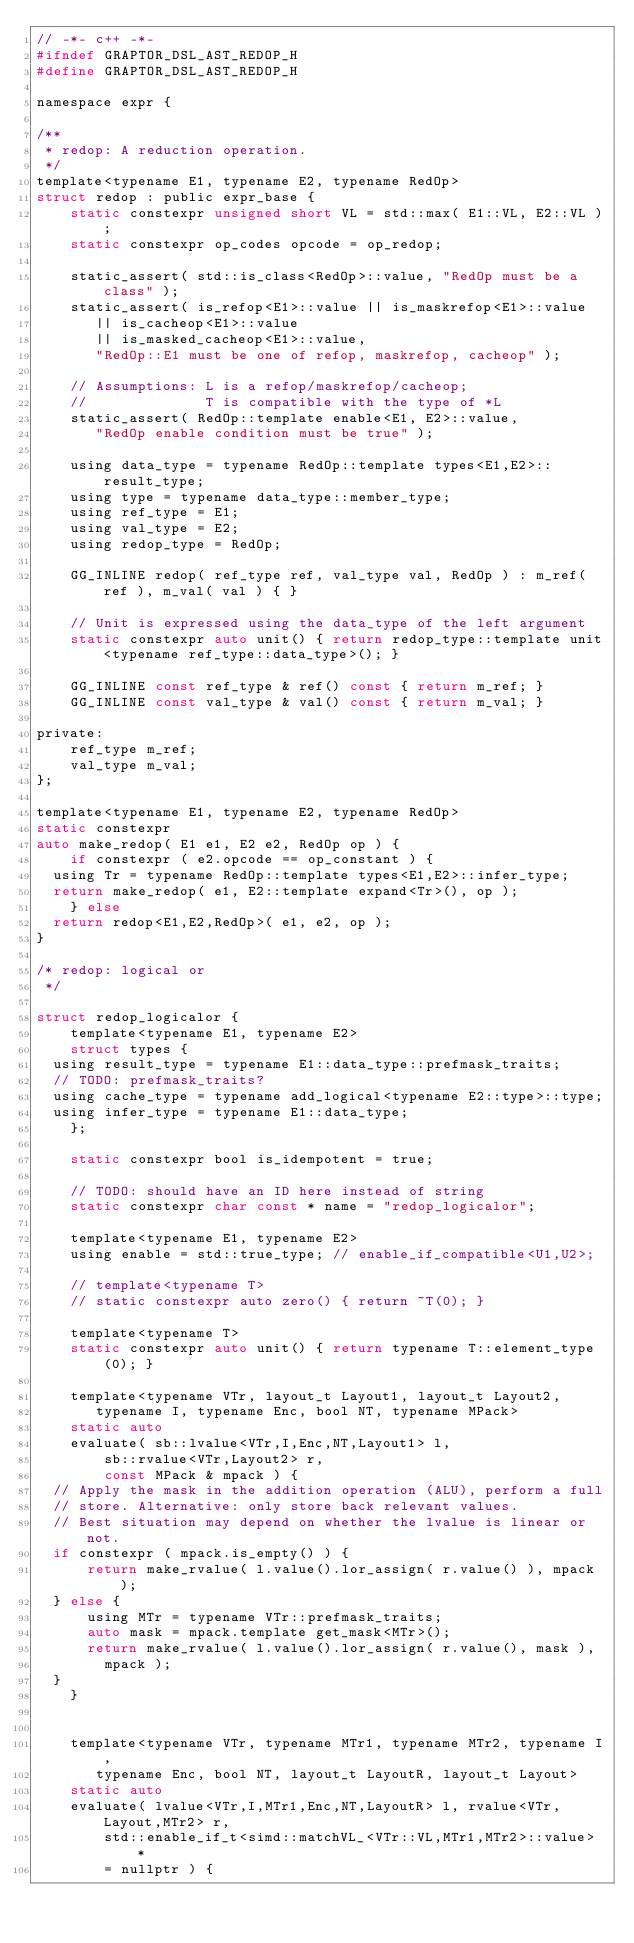<code> <loc_0><loc_0><loc_500><loc_500><_C_>// -*- c++ -*-
#ifndef GRAPTOR_DSL_AST_REDOP_H
#define GRAPTOR_DSL_AST_REDOP_H

namespace expr {

/**
 * redop: A reduction operation.
 */
template<typename E1, typename E2, typename RedOp>
struct redop : public expr_base {
    static constexpr unsigned short VL = std::max( E1::VL, E2::VL );
    static constexpr op_codes opcode = op_redop;

    static_assert( std::is_class<RedOp>::value, "RedOp must be a class" );
    static_assert( is_refop<E1>::value || is_maskrefop<E1>::value
		   || is_cacheop<E1>::value
		   || is_masked_cacheop<E1>::value,
		   "RedOp::E1 must be one of refop, maskrefop, cacheop" );

    // Assumptions: L is a refop/maskrefop/cacheop;
    //              T is compatible with the type of *L
    static_assert( RedOp::template enable<E1, E2>::value,
		   "RedOp enable condition must be true" );

    using data_type = typename RedOp::template types<E1,E2>::result_type;
    using type = typename data_type::member_type;
    using ref_type = E1;
    using val_type = E2;
    using redop_type = RedOp;

    GG_INLINE redop( ref_type ref, val_type val, RedOp ) : m_ref( ref ), m_val( val ) { }

    // Unit is expressed using the data_type of the left argument
    static constexpr auto unit() { return redop_type::template unit<typename ref_type::data_type>(); }

    GG_INLINE const ref_type & ref() const { return m_ref; }
    GG_INLINE const val_type & val() const { return m_val; }

private:
    ref_type m_ref;
    val_type m_val;
};

template<typename E1, typename E2, typename RedOp>
static constexpr
auto make_redop( E1 e1, E2 e2, RedOp op ) {
    if constexpr ( e2.opcode == op_constant ) {
	using Tr = typename RedOp::template types<E1,E2>::infer_type;
	return make_redop( e1, E2::template expand<Tr>(), op );
    } else
	return redop<E1,E2,RedOp>( e1, e2, op );
}

/* redop: logical or
 */

struct redop_logicalor {
    template<typename E1, typename E2>
    struct types {
	using result_type = typename E1::data_type::prefmask_traits;
	// TODO: prefmask_traits?
	using cache_type = typename add_logical<typename E2::type>::type;
	using infer_type = typename E1::data_type;
    };

    static constexpr bool is_idempotent = true;

    // TODO: should have an ID here instead of string
    static constexpr char const * name = "redop_logicalor";

    template<typename E1, typename E2>
    using enable = std::true_type; // enable_if_compatible<U1,U2>;

    // template<typename T>
    // static constexpr auto zero() { return ~T(0); }

    template<typename T>
    static constexpr auto unit() { return typename T::element_type(0); }

    template<typename VTr, layout_t Layout1, layout_t Layout2,
	     typename I, typename Enc, bool NT, typename MPack>
    static auto
    evaluate( sb::lvalue<VTr,I,Enc,NT,Layout1> l,
	      sb::rvalue<VTr,Layout2> r,
	      const MPack & mpack ) {
	// Apply the mask in the addition operation (ALU), perform a full
	// store. Alternative: only store back relevant values.
	// Best situation may depend on whether the lvalue is linear or not.
	if constexpr ( mpack.is_empty() ) {
	    return make_rvalue( l.value().lor_assign( r.value() ), mpack );
	} else {
	    using MTr = typename VTr::prefmask_traits;
	    auto mask = mpack.template get_mask<MTr>();
	    return make_rvalue( l.value().lor_assign( r.value(), mask ),
				mpack );
	} 
    }


    template<typename VTr, typename MTr1, typename MTr2, typename I,
	     typename Enc, bool NT, layout_t LayoutR, layout_t Layout>
    static auto
    evaluate( lvalue<VTr,I,MTr1,Enc,NT,LayoutR> l, rvalue<VTr,Layout,MTr2> r,
	      std::enable_if_t<simd::matchVL_<VTr::VL,MTr1,MTr2>::value> *
	      = nullptr ) {</code> 